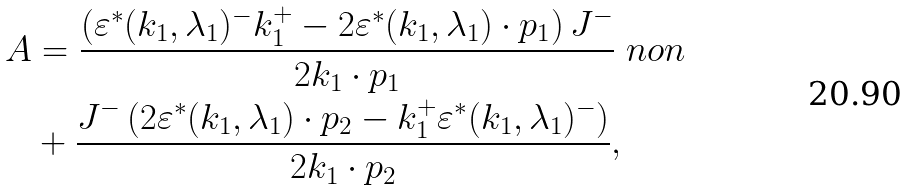Convert formula to latex. <formula><loc_0><loc_0><loc_500><loc_500>A & = \frac { \left ( \varepsilon ^ { * } ( k _ { 1 } , \lambda _ { 1 } ) ^ { - } k _ { 1 } ^ { + } - 2 \varepsilon ^ { * } ( k _ { 1 } , \lambda _ { 1 } ) \cdot p _ { 1 } \right ) J ^ { - } } { 2 k _ { 1 } \cdot p _ { 1 } } \ n o n \\ & + \frac { J ^ { - } \left ( 2 \varepsilon ^ { * } ( k _ { 1 } , \lambda _ { 1 } ) \cdot p _ { 2 } - k _ { 1 } ^ { + } \varepsilon ^ { * } ( k _ { 1 } , \lambda _ { 1 } ) ^ { - } \right ) } { 2 k _ { 1 } \cdot p _ { 2 } } ,</formula> 